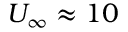<formula> <loc_0><loc_0><loc_500><loc_500>U _ { \infty } \approx 1 0</formula> 